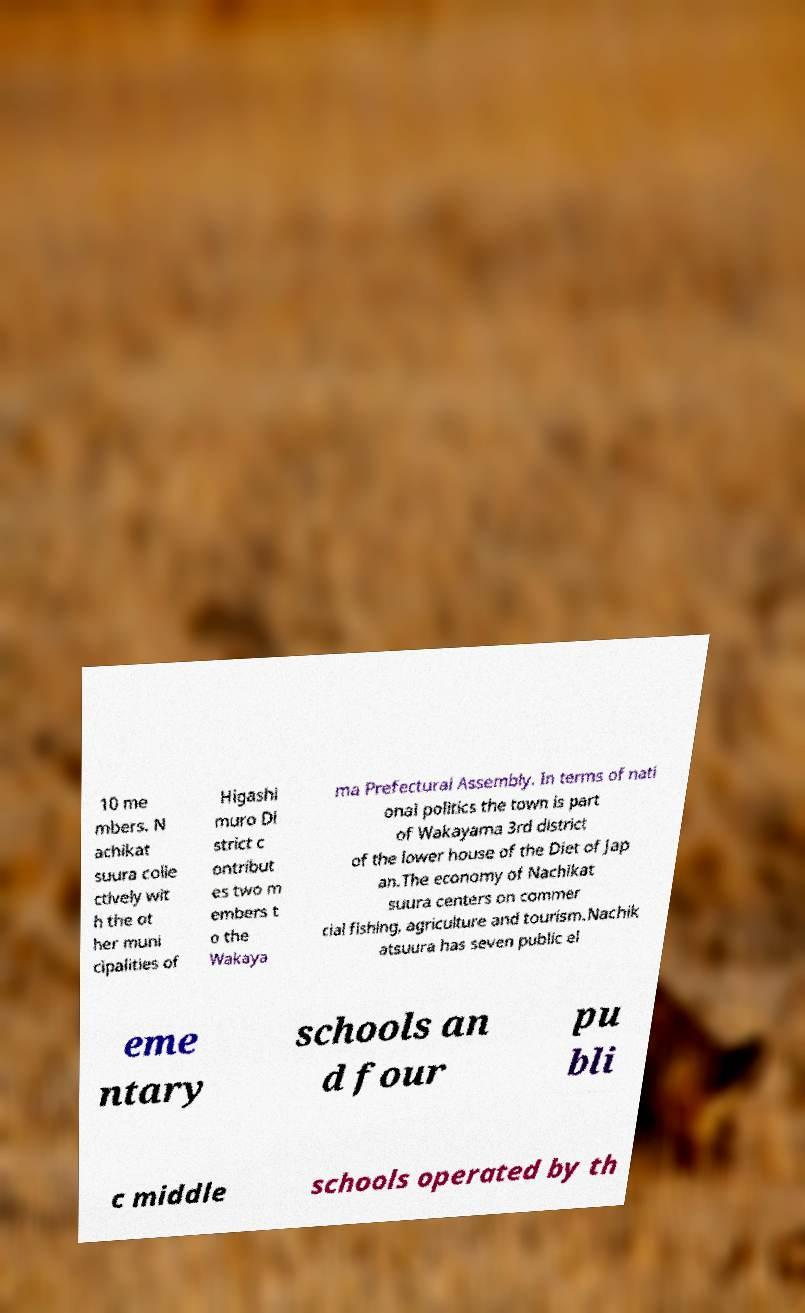Could you assist in decoding the text presented in this image and type it out clearly? 10 me mbers. N achikat suura colle ctively wit h the ot her muni cipalities of Higashi muro Di strict c ontribut es two m embers t o the Wakaya ma Prefectural Assembly. In terms of nati onal politics the town is part of Wakayama 3rd district of the lower house of the Diet of Jap an.The economy of Nachikat suura centers on commer cial fishing, agriculture and tourism.Nachik atsuura has seven public el eme ntary schools an d four pu bli c middle schools operated by th 